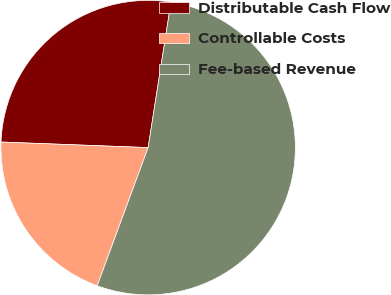Convert chart. <chart><loc_0><loc_0><loc_500><loc_500><pie_chart><fcel>Distributable Cash Flow<fcel>Controllable Costs<fcel>Fee-based Revenue<nl><fcel>26.88%<fcel>19.98%<fcel>53.14%<nl></chart> 